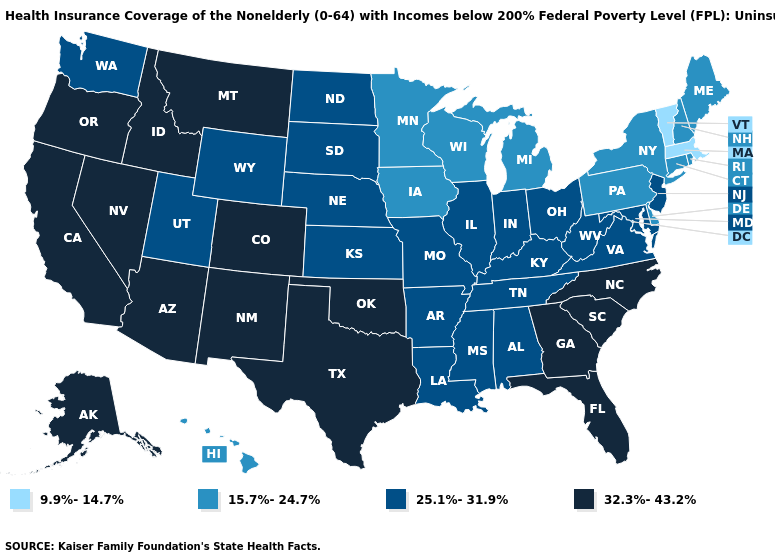Which states hav the highest value in the West?
Concise answer only. Alaska, Arizona, California, Colorado, Idaho, Montana, Nevada, New Mexico, Oregon. Which states have the lowest value in the USA?
Be succinct. Massachusetts, Vermont. Does Idaho have the highest value in the USA?
Answer briefly. Yes. Name the states that have a value in the range 9.9%-14.7%?
Be succinct. Massachusetts, Vermont. Name the states that have a value in the range 25.1%-31.9%?
Keep it brief. Alabama, Arkansas, Illinois, Indiana, Kansas, Kentucky, Louisiana, Maryland, Mississippi, Missouri, Nebraska, New Jersey, North Dakota, Ohio, South Dakota, Tennessee, Utah, Virginia, Washington, West Virginia, Wyoming. Name the states that have a value in the range 15.7%-24.7%?
Be succinct. Connecticut, Delaware, Hawaii, Iowa, Maine, Michigan, Minnesota, New Hampshire, New York, Pennsylvania, Rhode Island, Wisconsin. What is the value of Idaho?
Write a very short answer. 32.3%-43.2%. Does Wyoming have a lower value than Florida?
Keep it brief. Yes. What is the value of New Jersey?
Keep it brief. 25.1%-31.9%. What is the value of Nevada?
Give a very brief answer. 32.3%-43.2%. Among the states that border Iowa , does Minnesota have the highest value?
Concise answer only. No. Does the map have missing data?
Quick response, please. No. Does Vermont have the lowest value in the Northeast?
Quick response, please. Yes. Does Colorado have the same value as Nebraska?
Be succinct. No. What is the lowest value in the USA?
Quick response, please. 9.9%-14.7%. 